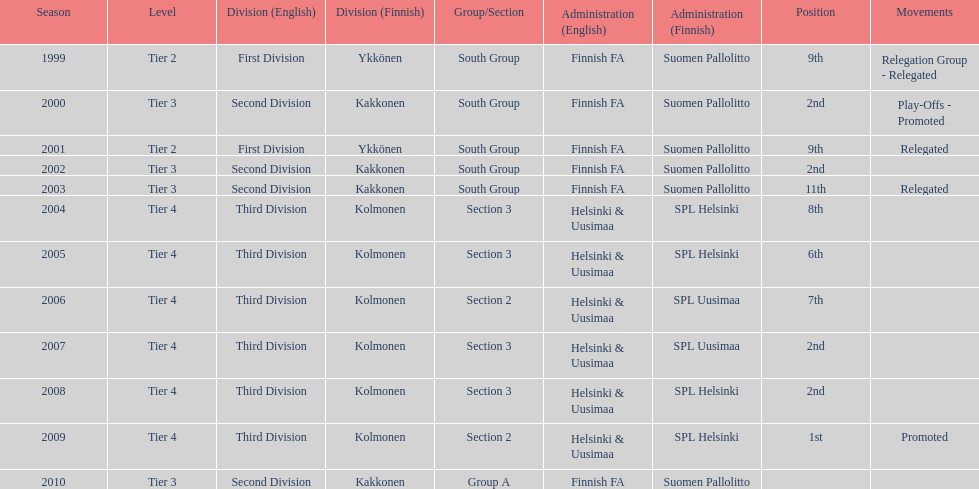How many times were they in tier 3? 4. 